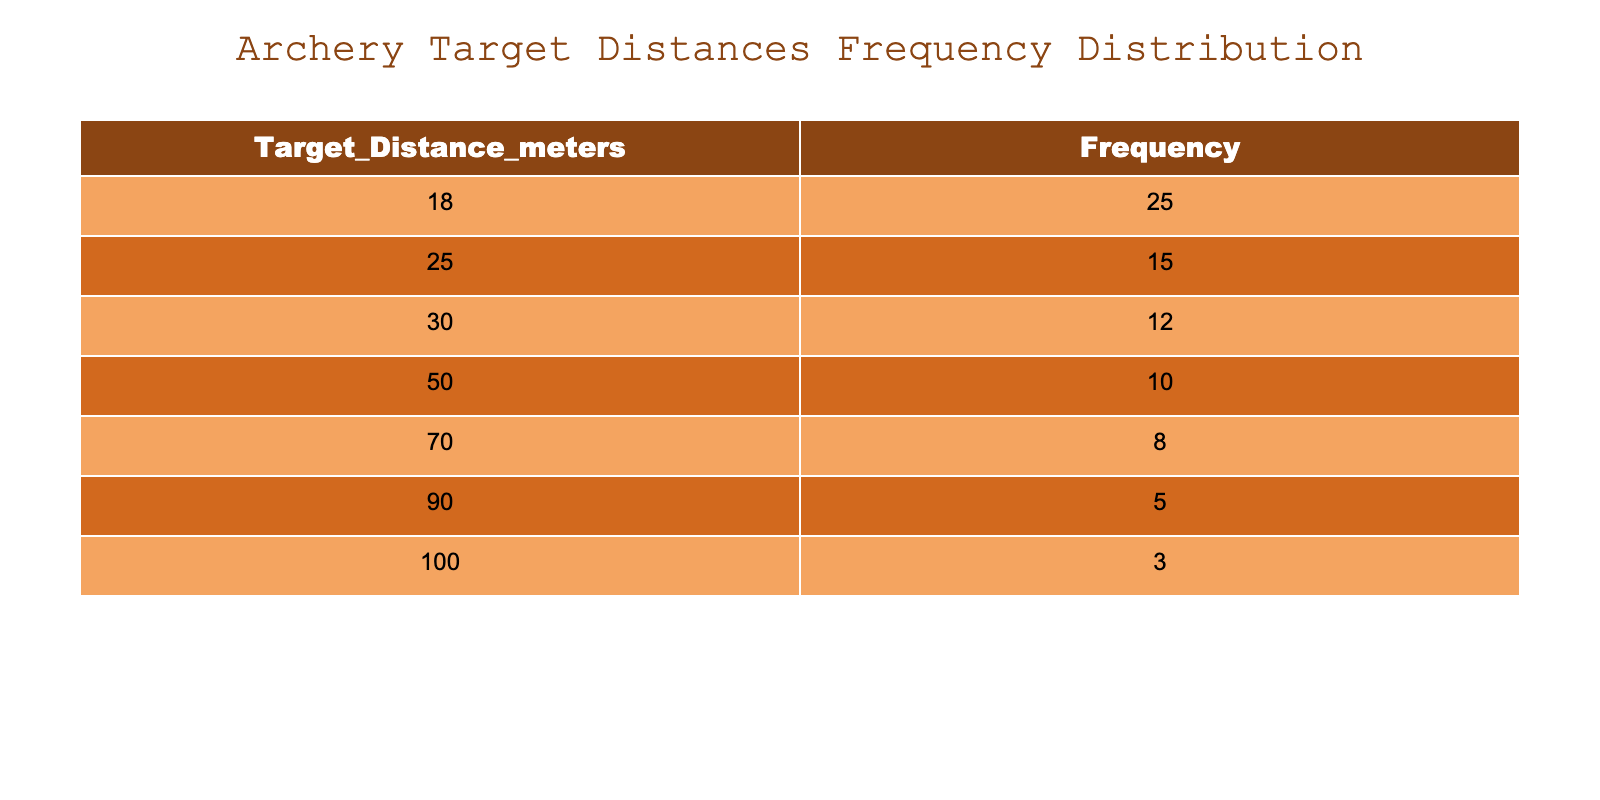What is the frequency of the 30-meter target distance? The table lists the frequency for each target distance, and under the column for 30 meters, the frequency stated is 12.
Answer: 12 What is the total frequency for all target distances? To find the total frequency, we need to add all the frequencies in the table. The frequencies are 25, 15, 12, 10, 8, 5, 3. Adding them gives (25 + 15 + 12 + 10 + 8 + 5 + 3) = 78.
Answer: 78 Is there a target distance with a frequency greater than 20? By examining the frequency column, we see that only the 18-meter target distance has a frequency of 25, which is greater than 20.
Answer: Yes What is the average (mean) frequency of the target distances? To calculate the average frequency, we sum the frequencies (25 + 15 + 12 + 10 + 8 + 5 + 3 = 78) and divide by the number of categories, which is 7. Thus, the average is 78/7 = approximately 11.14.
Answer: Approximately 11.14 Which target distance has the lowest frequency? Looking at the frequency column, the 100-meter distance has the lowest frequency, which is 3.
Answer: 100 meters How many target distances have a frequency of 10 or less? We need to identify the frequencies that are 10 or less from the table. The frequencies below or equal to 10 are 10, 8, 5, and 3, associated with distances 50, 70, 90, and 100. Counting these gives us 4 target distances.
Answer: 4 What is the difference in frequency between the 18-meter and 100-meter target distances? The frequency for the 18-meter distance is 25, and for the 100-meter distance, it is 3. The difference is calculated as 25 - 3 = 22.
Answer: 22 Are there more target distances with frequencies above or below 10? Analyzing the frequencies, those above 10 are 25 (18m), 15 (25m), and 12 (30m), which counts as 3. The frequencies below or equal to 10 are 10 (50m), 8 (70m), 5 (90m), and 3 (100m), which counts as 4. Therefore, there are more distances with frequencies below 10.
Answer: Below 10 What is the frequency for target distances greater than 70 meters? We assess the frequencies for target distances greater than 70 meters, which are 90 meters (5) and 100 meters (3). Adding these gives 5 + 3 = 8.
Answer: 8 